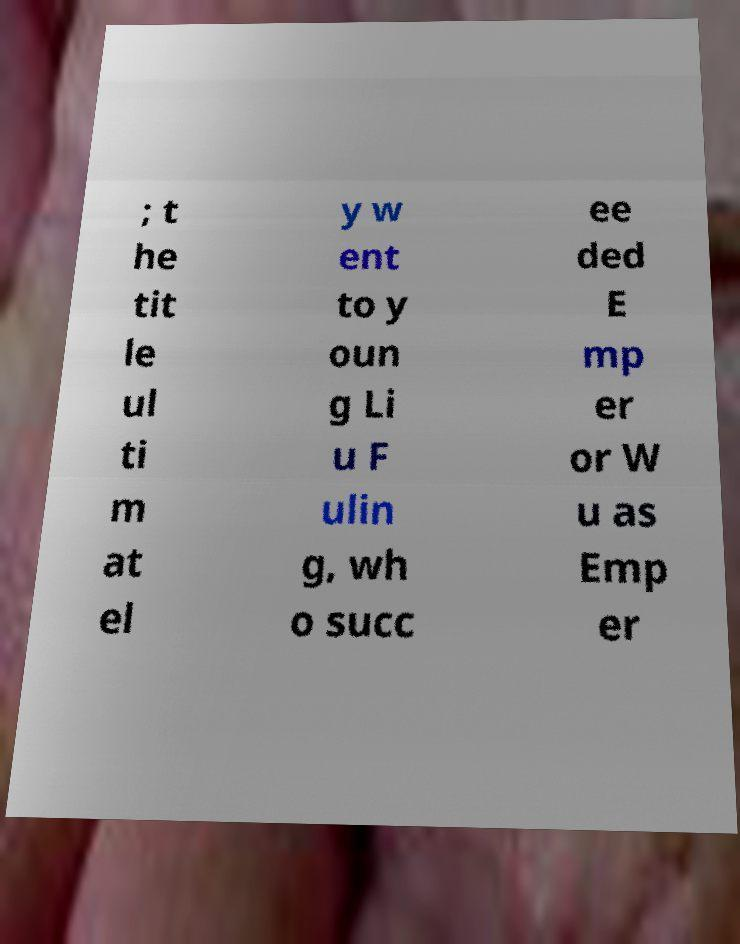Can you read and provide the text displayed in the image?This photo seems to have some interesting text. Can you extract and type it out for me? ; t he tit le ul ti m at el y w ent to y oun g Li u F ulin g, wh o succ ee ded E mp er or W u as Emp er 